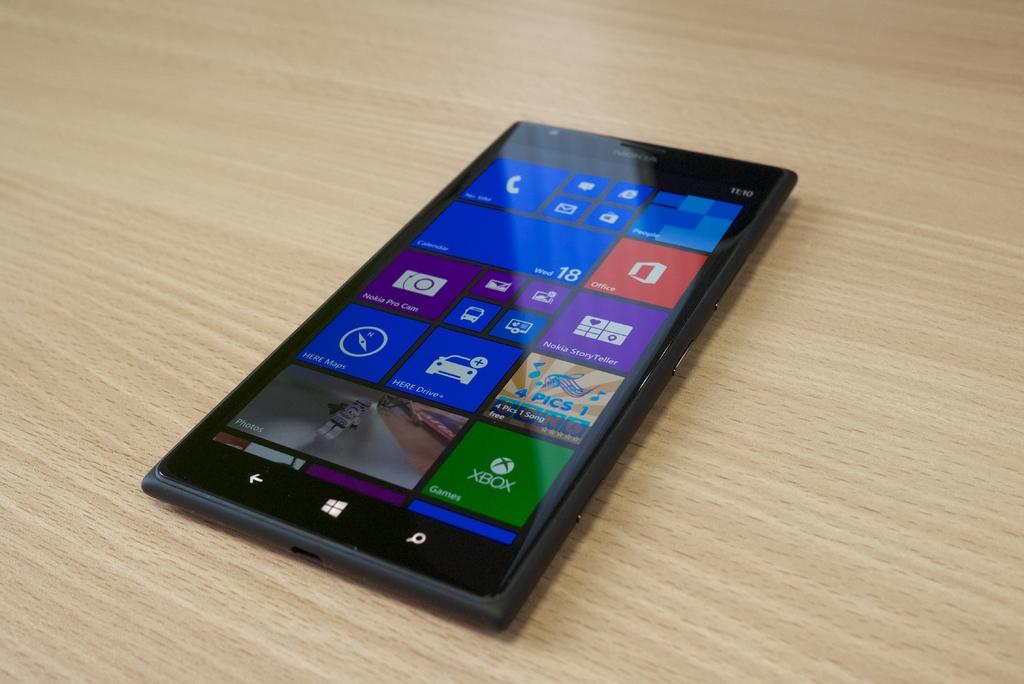<image>
Write a terse but informative summary of the picture. A Nokia cell phone has the time of 11:10 in the upper right hand corner. 